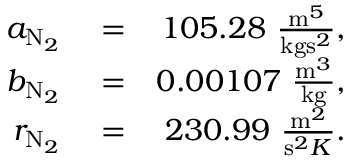Convert formula to latex. <formula><loc_0><loc_0><loc_500><loc_500>\begin{array} { r l r } { a _ { N _ { 2 } } } & = } & { 1 0 5 . 2 8 \frac { m ^ { 5 } } { k g s ^ { 2 } } , } \\ { b _ { N _ { 2 } } } & = } & { 0 . 0 0 1 0 7 \frac { m ^ { 3 } } { k g } , } \\ { r _ { N _ { 2 } } } & = } & { 2 3 0 . 9 9 \frac { m ^ { 2 } } { s ^ { 2 } K } . } \end{array}</formula> 